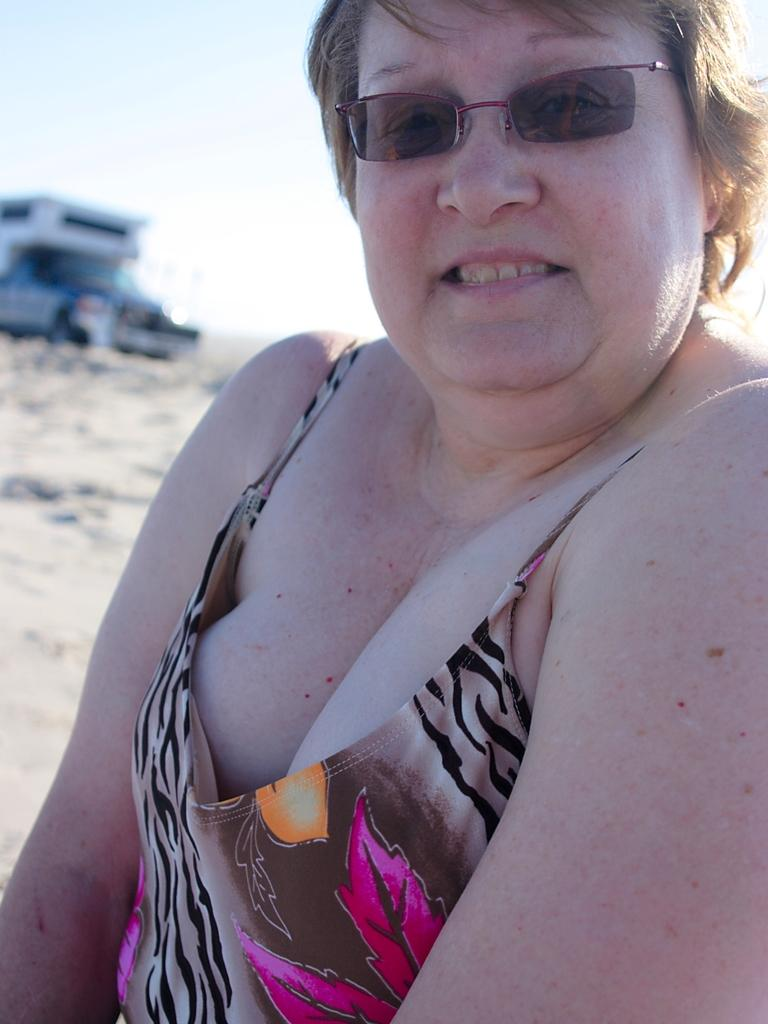Who is the main subject in the image? There is a woman in the front of the image. What is the woman wearing? The woman is wearing spectacles. What can be seen in the background of the image? There is a vehicle in the background of the image. What is visible at the top of the image? The sky is visible at the top of the image. What type of nut is the woman holding in the image? There is no nut present in the image; the woman is not holding anything. 